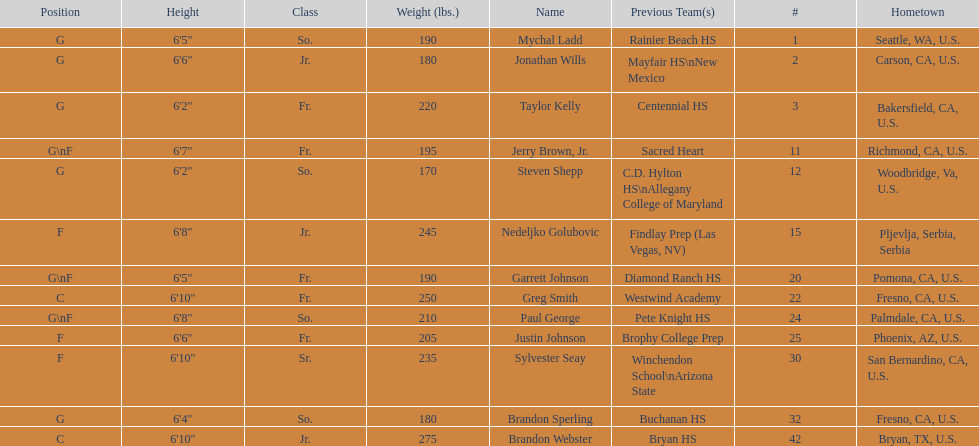Would you mind parsing the complete table? {'header': ['Position', 'Height', 'Class', 'Weight (lbs.)', 'Name', 'Previous Team(s)', '#', 'Hometown'], 'rows': [['G', '6\'5"', 'So.', '190', 'Mychal Ladd', 'Rainier Beach HS', '1', 'Seattle, WA, U.S.'], ['G', '6\'6"', 'Jr.', '180', 'Jonathan Wills', 'Mayfair HS\\nNew Mexico', '2', 'Carson, CA, U.S.'], ['G', '6\'2"', 'Fr.', '220', 'Taylor Kelly', 'Centennial HS', '3', 'Bakersfield, CA, U.S.'], ['G\\nF', '6\'7"', 'Fr.', '195', 'Jerry Brown, Jr.', 'Sacred Heart', '11', 'Richmond, CA, U.S.'], ['G', '6\'2"', 'So.', '170', 'Steven Shepp', 'C.D. Hylton HS\\nAllegany College of Maryland', '12', 'Woodbridge, Va, U.S.'], ['F', '6\'8"', 'Jr.', '245', 'Nedeljko Golubovic', 'Findlay Prep (Las Vegas, NV)', '15', 'Pljevlja, Serbia, Serbia'], ['G\\nF', '6\'5"', 'Fr.', '190', 'Garrett Johnson', 'Diamond Ranch HS', '20', 'Pomona, CA, U.S.'], ['C', '6\'10"', 'Fr.', '250', 'Greg Smith', 'Westwind Academy', '22', 'Fresno, CA, U.S.'], ['G\\nF', '6\'8"', 'So.', '210', 'Paul George', 'Pete Knight HS', '24', 'Palmdale, CA, U.S.'], ['F', '6\'6"', 'Fr.', '205', 'Justin Johnson', 'Brophy College Prep', '25', 'Phoenix, AZ, U.S.'], ['F', '6\'10"', 'Sr.', '235', 'Sylvester Seay', 'Winchendon School\\nArizona State', '30', 'San Bernardino, CA, U.S.'], ['G', '6\'4"', 'So.', '180', 'Brandon Sperling', 'Buchanan HS', '32', 'Fresno, CA, U.S.'], ['C', '6\'10"', 'Jr.', '275', 'Brandon Webster', 'Bryan HS', '42', 'Bryan, TX, U.S.']]} Who weighs the most on the team? Brandon Webster. 